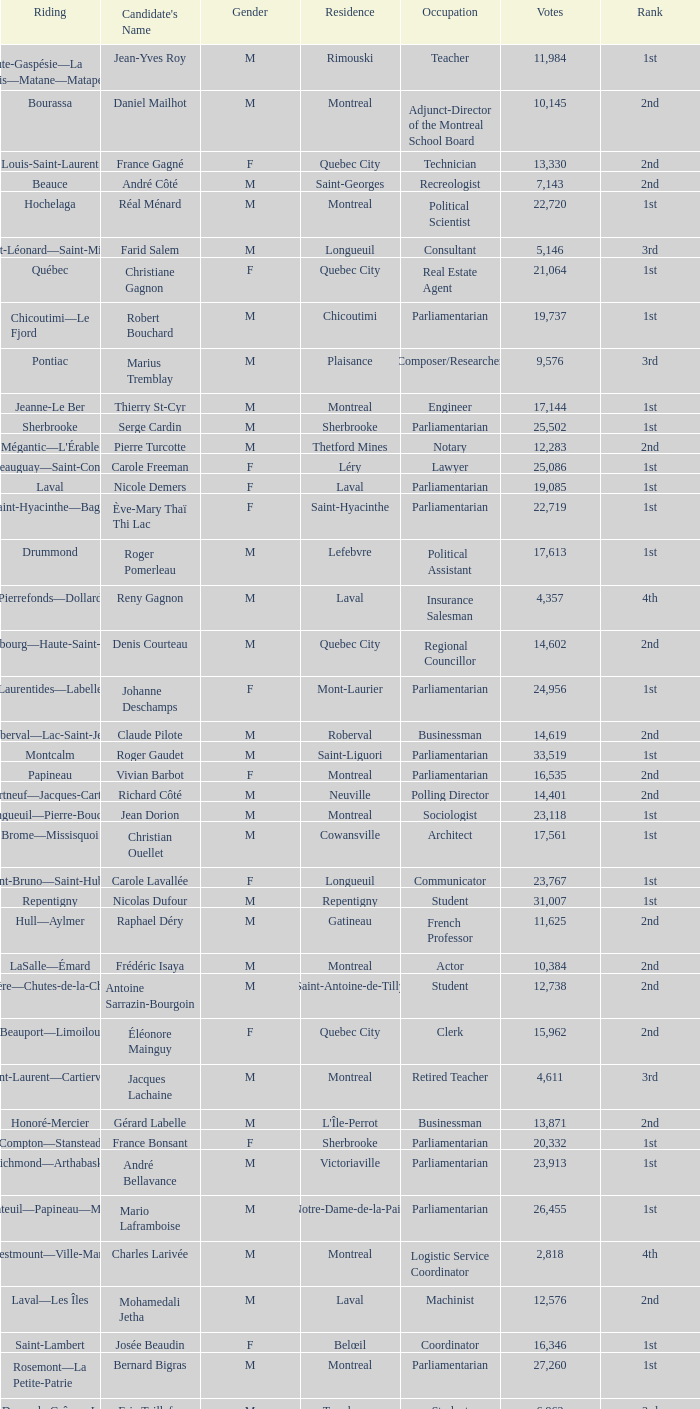What is the highest number of votes for the French Professor? 11625.0. 